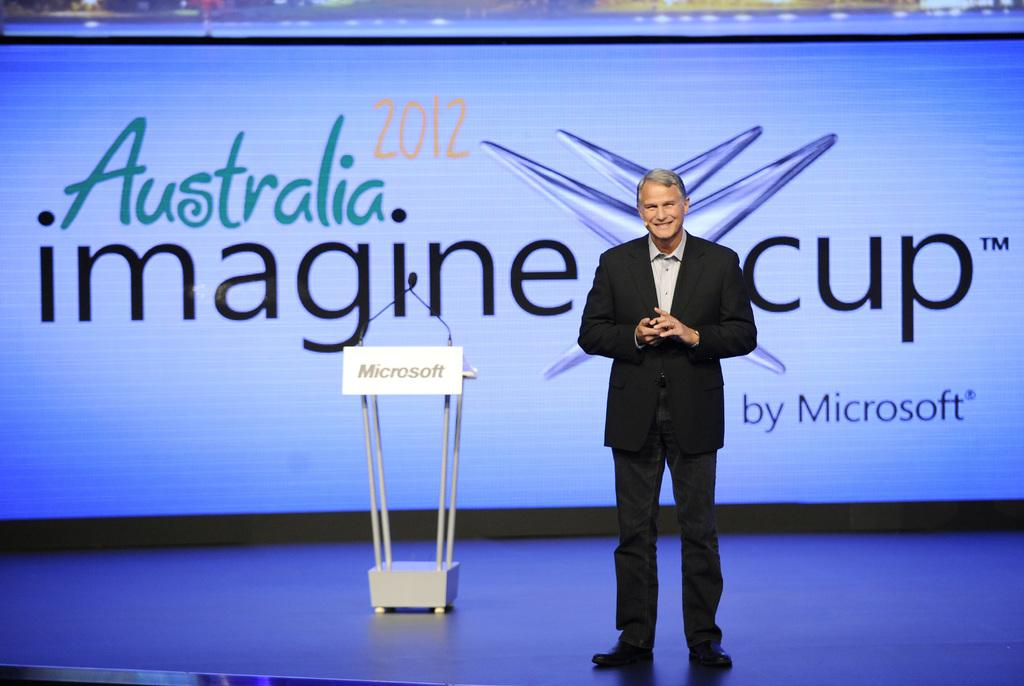What is happening on the stage in the image? There is a person standing on the stage. What object is on the stage that the person might use? There is a podium with a microphone on the stage. What can be seen in the background of the image? There is text written on the wall in the background. How many cattle are visible in the image? There are no cattle present in the image. What type of pies are being served on the stage? There is no mention of pies in the image; it features a person standing on the stage with a podium and microphone. 